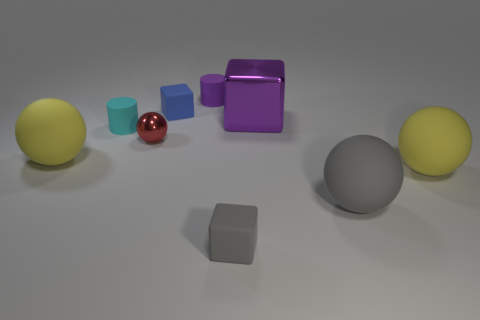What is the material of the big gray sphere?
Your answer should be very brief. Rubber. Are there any purple matte things that have the same size as the gray cube?
Provide a succinct answer. Yes. There is a gray thing that is the same size as the blue cube; what material is it?
Your response must be concise. Rubber. How many tiny blue rubber objects are there?
Your answer should be very brief. 1. How big is the yellow ball that is left of the tiny cyan matte cylinder?
Offer a terse response. Large. Are there the same number of purple rubber objects in front of the big purple metal block and small purple rubber cylinders?
Make the answer very short. No. Is there a big purple thing of the same shape as the tiny shiny object?
Make the answer very short. No. The matte thing that is to the left of the tiny gray matte cube and in front of the red shiny thing has what shape?
Your answer should be very brief. Sphere. Are the gray cube and the large yellow object that is right of the gray matte cube made of the same material?
Make the answer very short. Yes. There is a purple metallic thing; are there any tiny objects right of it?
Provide a short and direct response. No. 